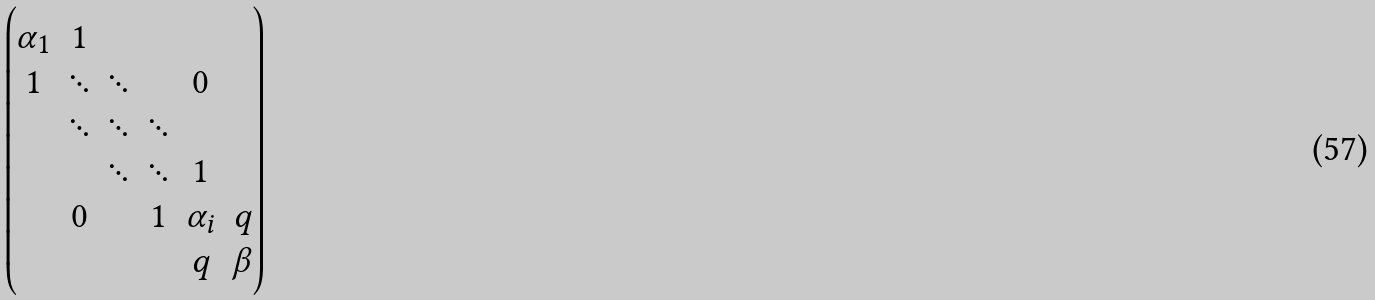<formula> <loc_0><loc_0><loc_500><loc_500>\begin{pmatrix} \alpha _ { 1 } & 1 & & & & \\ 1 & \ddots & \ddots & & 0 & \\ & \ddots & \ddots & \ddots & & \\ & & \ddots & \ddots & 1 & \\ & 0 & & 1 & \alpha _ { i } & q \\ & & & & q & \beta \end{pmatrix}</formula> 